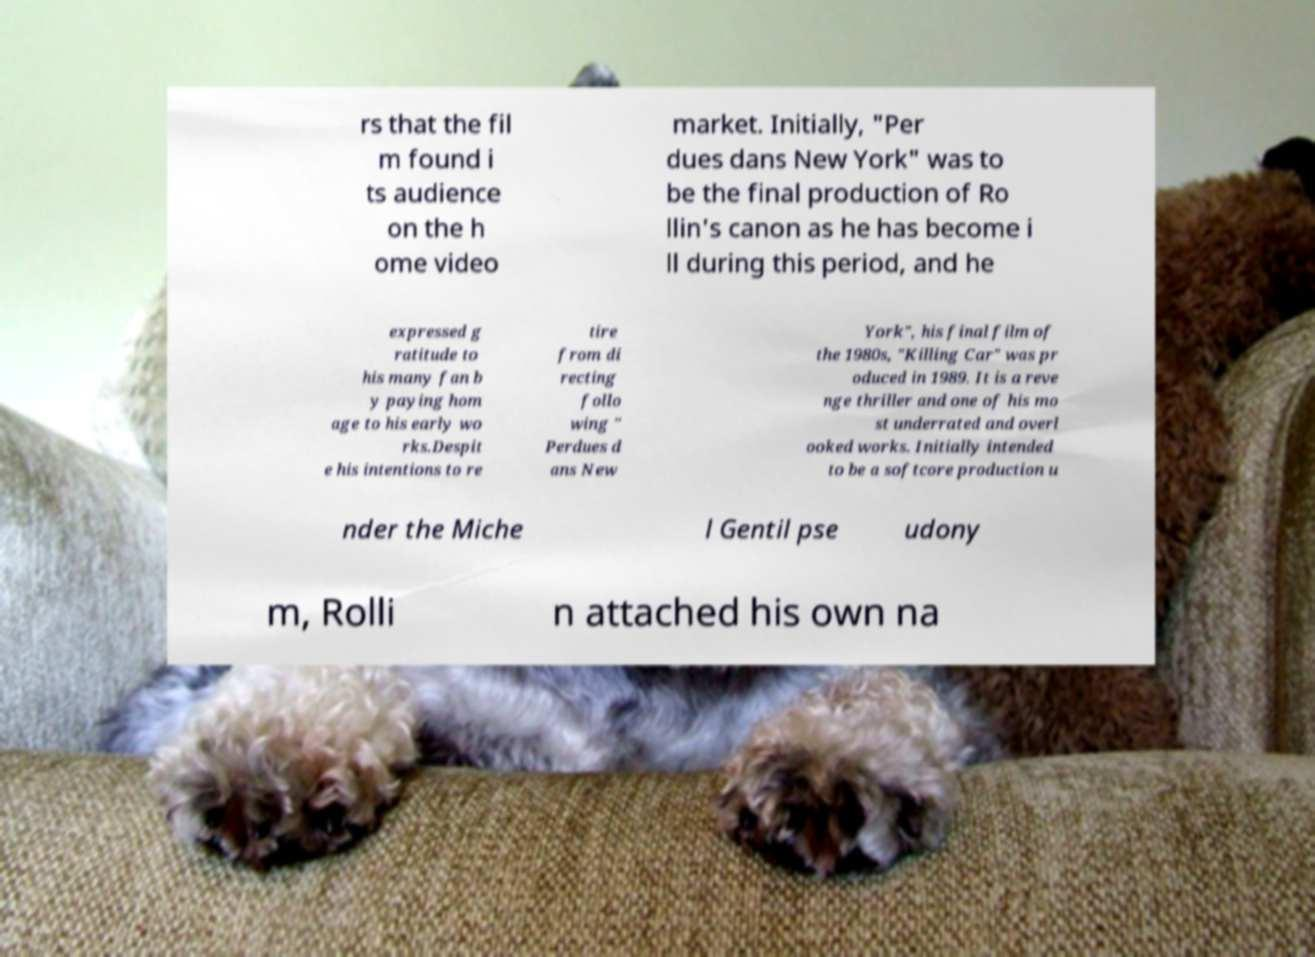What messages or text are displayed in this image? I need them in a readable, typed format. rs that the fil m found i ts audience on the h ome video market. Initially, "Per dues dans New York" was to be the final production of Ro llin's canon as he has become i ll during this period, and he expressed g ratitude to his many fan b y paying hom age to his early wo rks.Despit e his intentions to re tire from di recting follo wing " Perdues d ans New York", his final film of the 1980s, "Killing Car" was pr oduced in 1989. It is a reve nge thriller and one of his mo st underrated and overl ooked works. Initially intended to be a softcore production u nder the Miche l Gentil pse udony m, Rolli n attached his own na 